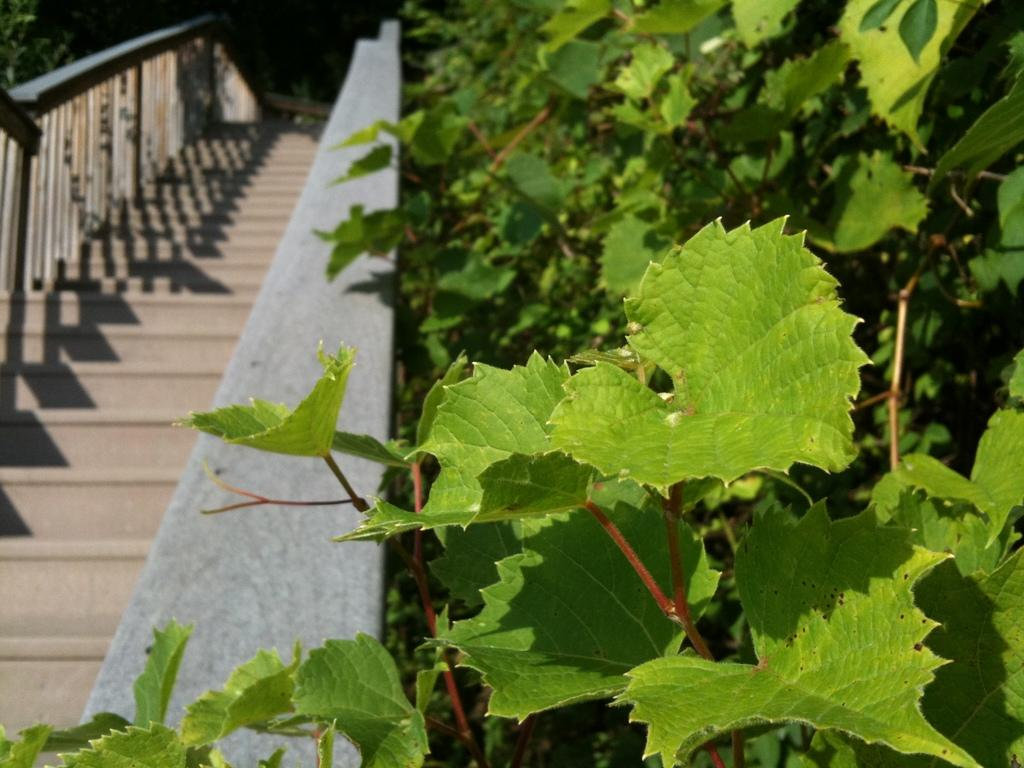What is located in front of the image? There are plants in front of the image. Where are more plants located in the image? There are plants on the left side of the image. What architectural feature can be seen on the left side of the image? There are steps visible on the left side of the image. What type of division is taking place in the image? There is no division present in the image; it features plants and steps. Is there a scarf visible on the steps in the image? There is no scarf present in the image. 